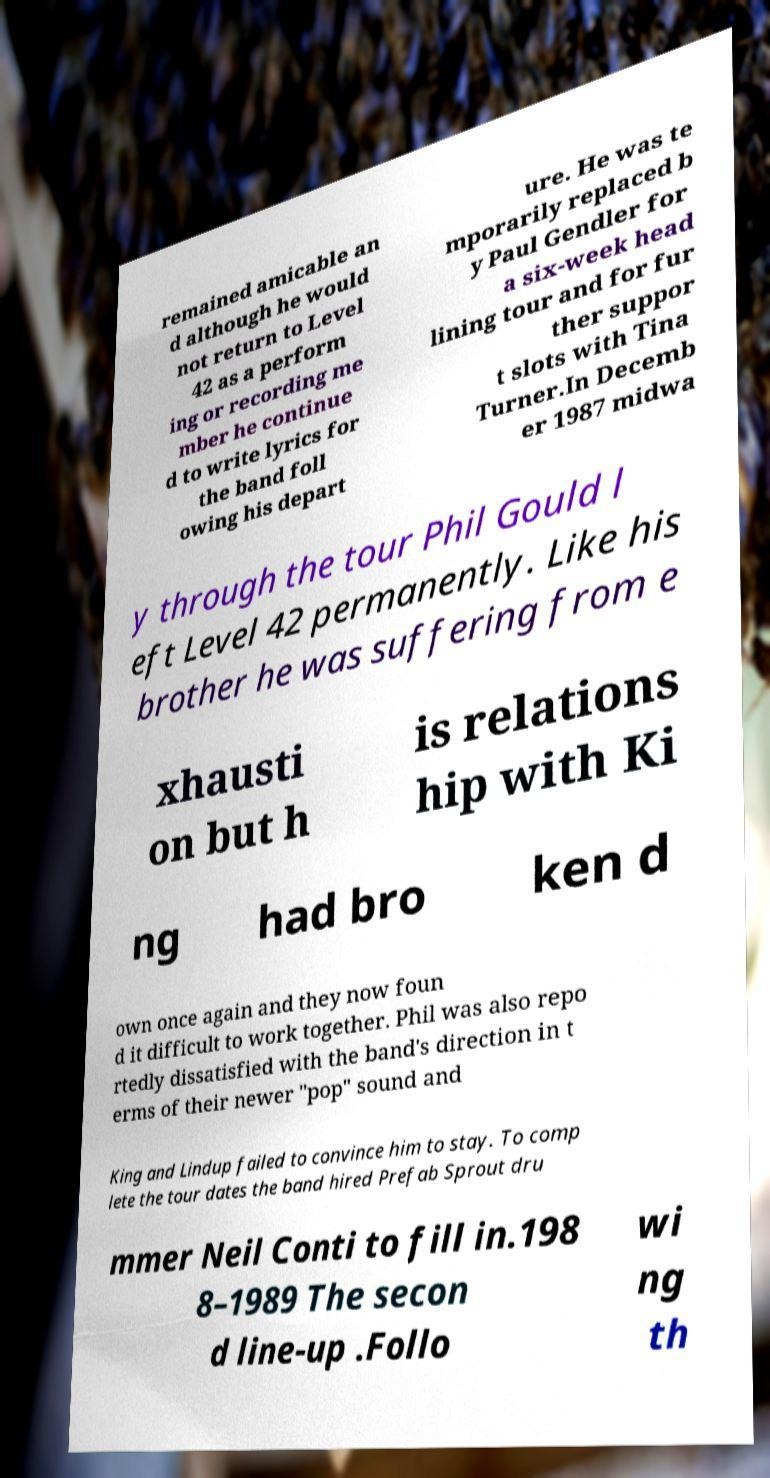Please identify and transcribe the text found in this image. remained amicable an d although he would not return to Level 42 as a perform ing or recording me mber he continue d to write lyrics for the band foll owing his depart ure. He was te mporarily replaced b y Paul Gendler for a six-week head lining tour and for fur ther suppor t slots with Tina Turner.In Decemb er 1987 midwa y through the tour Phil Gould l eft Level 42 permanently. Like his brother he was suffering from e xhausti on but h is relations hip with Ki ng had bro ken d own once again and they now foun d it difficult to work together. Phil was also repo rtedly dissatisfied with the band's direction in t erms of their newer "pop" sound and King and Lindup failed to convince him to stay. To comp lete the tour dates the band hired Prefab Sprout dru mmer Neil Conti to fill in.198 8–1989 The secon d line-up .Follo wi ng th 